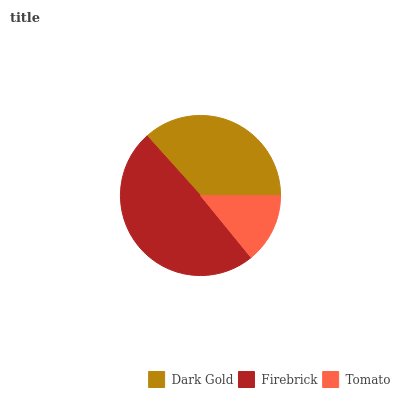Is Tomato the minimum?
Answer yes or no. Yes. Is Firebrick the maximum?
Answer yes or no. Yes. Is Firebrick the minimum?
Answer yes or no. No. Is Tomato the maximum?
Answer yes or no. No. Is Firebrick greater than Tomato?
Answer yes or no. Yes. Is Tomato less than Firebrick?
Answer yes or no. Yes. Is Tomato greater than Firebrick?
Answer yes or no. No. Is Firebrick less than Tomato?
Answer yes or no. No. Is Dark Gold the high median?
Answer yes or no. Yes. Is Dark Gold the low median?
Answer yes or no. Yes. Is Firebrick the high median?
Answer yes or no. No. Is Tomato the low median?
Answer yes or no. No. 